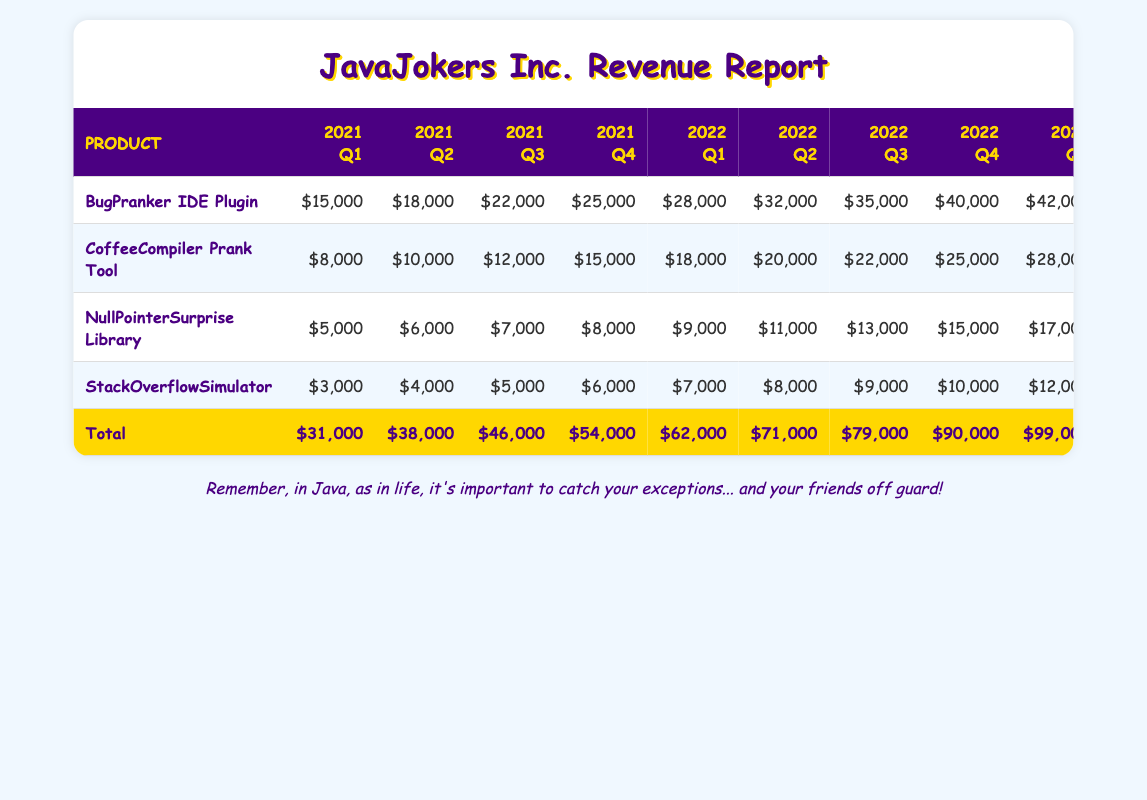What was the total revenue from the BugPranker IDE Plugin in 2022? To find the total revenue for the BugPranker IDE Plugin in 2022, I will add the revenues for each quarter in that year. The revenues for 2022 are $28,000 in Q1, $32,000 in Q2, $35,000 in Q3, and $40,000 in Q4. Adding these together: 28,000 + 32,000 + 35,000 + 40,000 = 135,000.
Answer: 135,000 Which product generated the highest revenue in Q4 of 2023? In Q4 of 2023, I will look at the revenue figures for the last column of each product. The revenues are: BugPranker - $52,000, CoffeeCompiler - $35,000, NullPointerSurprise - $23,000, and StackOverflowSimulator - $18,000. The highest value is $52,000 from the BugPranker IDE Plugin.
Answer: BugPranker IDE Plugin What is the average revenue of the NullPointerSurprise Library over all quarters in 2023? To find the average for the NullPointerSurprise Library in 2023, I will add its revenues for each quarter, which are $17,000, $19,000, $21,000, and $23,000, resulting in a total of 17,000 + 19,000 + 21,000 + 23,000 = 80,000. There are 4 quarters, so the average is 80,000 / 4 = 20,000.
Answer: 20,000 Was the total revenue from all products in Q1 of 2021 greater than the total in Q1 of 2023? For Q1 of 2021, the total revenue from all products is $15,000 (BugPranker) + $8,000 (CoffeeCompiler) + $5,000 (NullPointerSurprise) + $3,000 (StackOverflowSimulator) = $31,000. For Q1 of 2023, it is $42,000 (BugPranker) + $28,000 (CoffeeCompiler) + $17,000 (NullPointerSurprise) + $12,000 (StackOverflowSimulator) = $99,000. Since $31,000 is less than $99,000, the statement is false.
Answer: No What was the total revenue from selling the CoffeeCompiler Prank Tool in 2022 compared to 2021? In 2021, the total revenue from the CoffeeCompiler Prank Tool is: $8,000 + $10,000 + $12,000 + $15,000 = $45,000. In 2022, the total is: $18,000 + $20,000 + $22,000 + $25,000 = $85,000. Therefore, the 2022 revenue ($85,000) is greater than the 2021 revenue ($45,000).
Answer: Yes 